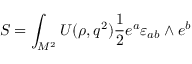<formula> <loc_0><loc_0><loc_500><loc_500>S = \int _ { M ^ { 2 } } U ( \rho , q ^ { 2 } ) { \frac { 1 } { 2 } } e ^ { a } \varepsilon _ { a b } \wedge e ^ { b }</formula> 